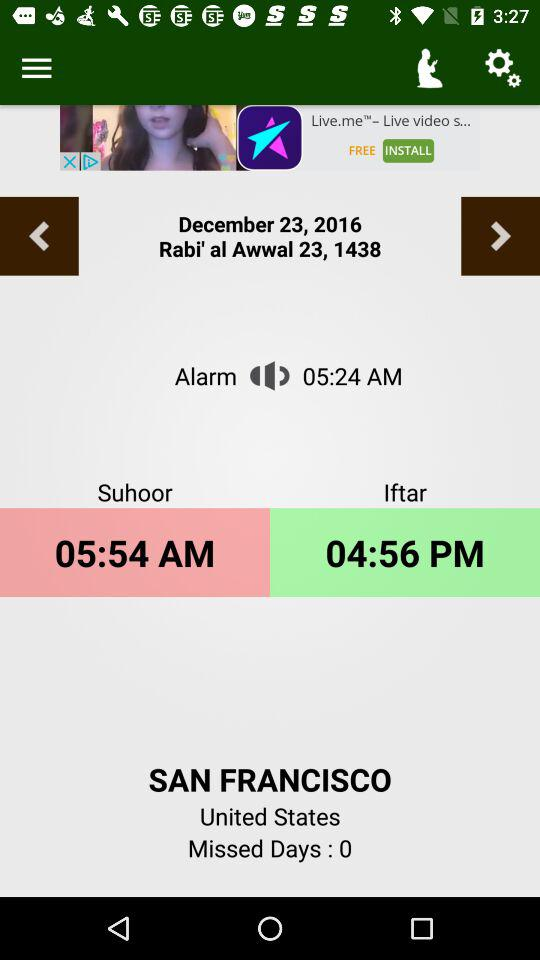What location is given? The given location is San Francisco,United States. 